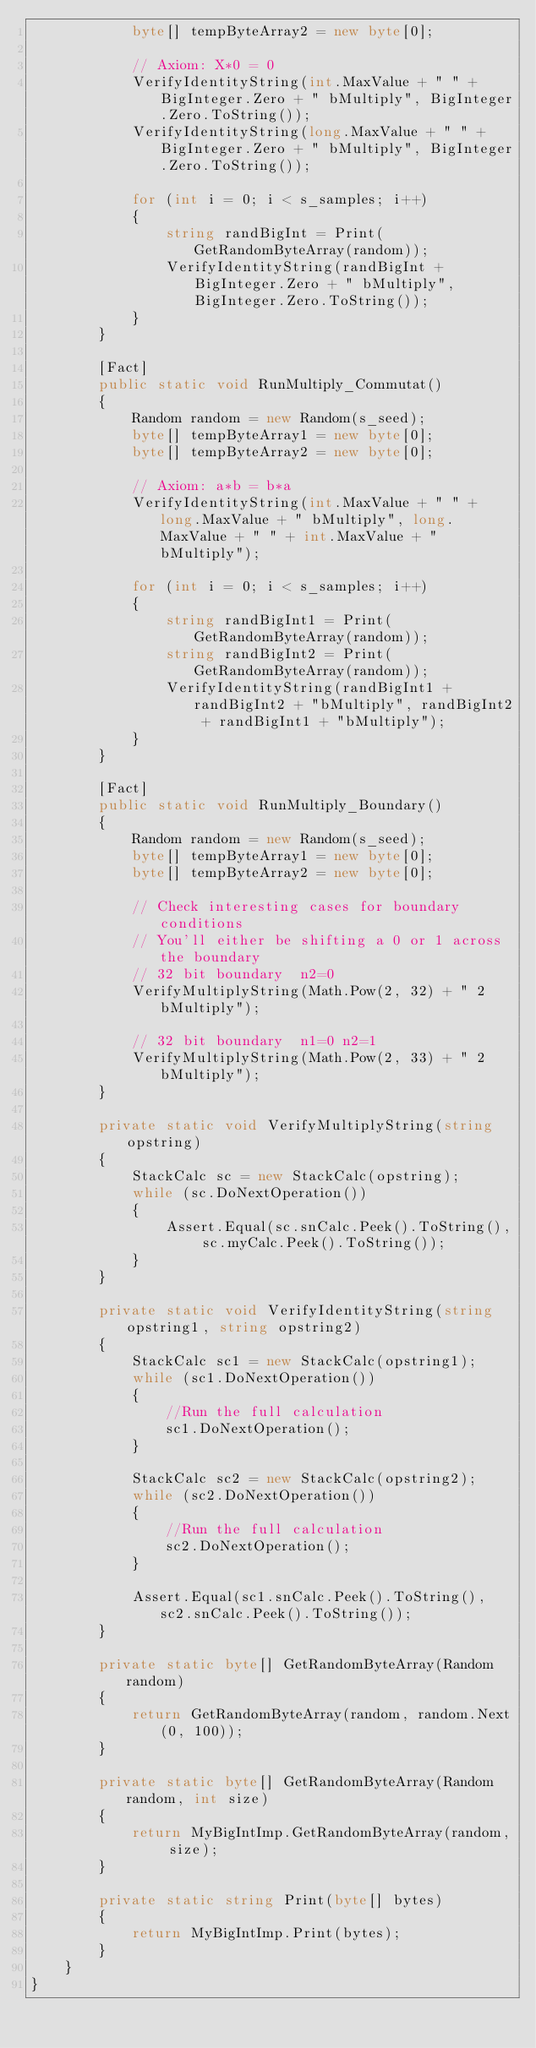Convert code to text. <code><loc_0><loc_0><loc_500><loc_500><_C#_>            byte[] tempByteArray2 = new byte[0];

            // Axiom: X*0 = 0
            VerifyIdentityString(int.MaxValue + " " + BigInteger.Zero + " bMultiply", BigInteger.Zero.ToString());
            VerifyIdentityString(long.MaxValue + " " + BigInteger.Zero + " bMultiply", BigInteger.Zero.ToString());

            for (int i = 0; i < s_samples; i++)
            {
                string randBigInt = Print(GetRandomByteArray(random));
                VerifyIdentityString(randBigInt + BigInteger.Zero + " bMultiply", BigInteger.Zero.ToString());
            }
        }

        [Fact]
        public static void RunMultiply_Commutat()
        {
            Random random = new Random(s_seed);
            byte[] tempByteArray1 = new byte[0];
            byte[] tempByteArray2 = new byte[0];

            // Axiom: a*b = b*a
            VerifyIdentityString(int.MaxValue + " " + long.MaxValue + " bMultiply", long.MaxValue + " " + int.MaxValue + " bMultiply");

            for (int i = 0; i < s_samples; i++)
            {
                string randBigInt1 = Print(GetRandomByteArray(random));
                string randBigInt2 = Print(GetRandomByteArray(random));
                VerifyIdentityString(randBigInt1 + randBigInt2 + "bMultiply", randBigInt2 + randBigInt1 + "bMultiply");
            }
        }

        [Fact]
        public static void RunMultiply_Boundary()
        {
            Random random = new Random(s_seed);
            byte[] tempByteArray1 = new byte[0];
            byte[] tempByteArray2 = new byte[0];

            // Check interesting cases for boundary conditions
            // You'll either be shifting a 0 or 1 across the boundary
            // 32 bit boundary  n2=0
            VerifyMultiplyString(Math.Pow(2, 32) + " 2 bMultiply");

            // 32 bit boundary  n1=0 n2=1
            VerifyMultiplyString(Math.Pow(2, 33) + " 2 bMultiply");
        }

        private static void VerifyMultiplyString(string opstring)
        {
            StackCalc sc = new StackCalc(opstring);
            while (sc.DoNextOperation())
            {
                Assert.Equal(sc.snCalc.Peek().ToString(), sc.myCalc.Peek().ToString());
            }
        }

        private static void VerifyIdentityString(string opstring1, string opstring2)
        {
            StackCalc sc1 = new StackCalc(opstring1);
            while (sc1.DoNextOperation())
            {	
                //Run the full calculation
                sc1.DoNextOperation();
            }

            StackCalc sc2 = new StackCalc(opstring2);
            while (sc2.DoNextOperation())
            {	
                //Run the full calculation
                sc2.DoNextOperation();
            }

            Assert.Equal(sc1.snCalc.Peek().ToString(), sc2.snCalc.Peek().ToString());
        }

        private static byte[] GetRandomByteArray(Random random)
        {
            return GetRandomByteArray(random, random.Next(0, 100));
        }

        private static byte[] GetRandomByteArray(Random random, int size)
        {
            return MyBigIntImp.GetRandomByteArray(random, size);
        }

        private static string Print(byte[] bytes)
        {
            return MyBigIntImp.Print(bytes);
        }
    }
}
</code> 